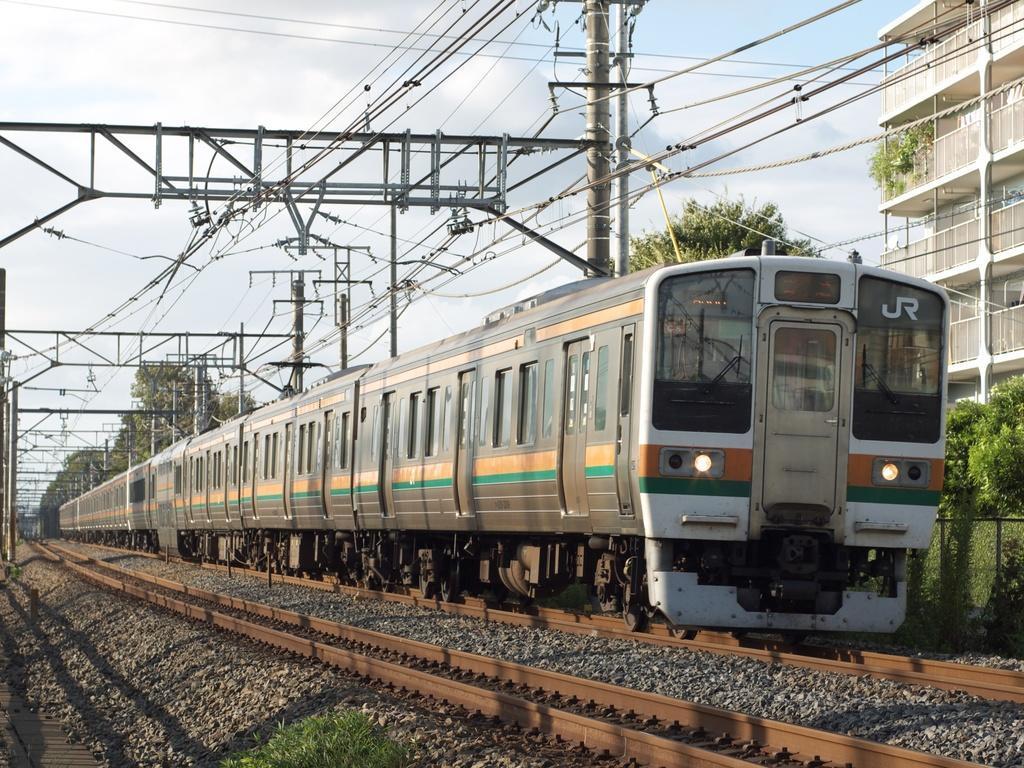How would you summarize this image in a sentence or two? In this image we can see a train on the railway track and there is another railway track, stones, plants and fence. In the background we can see rods, wires, trees, building on the left side, railings, poles, wires and clouds in the sky. 